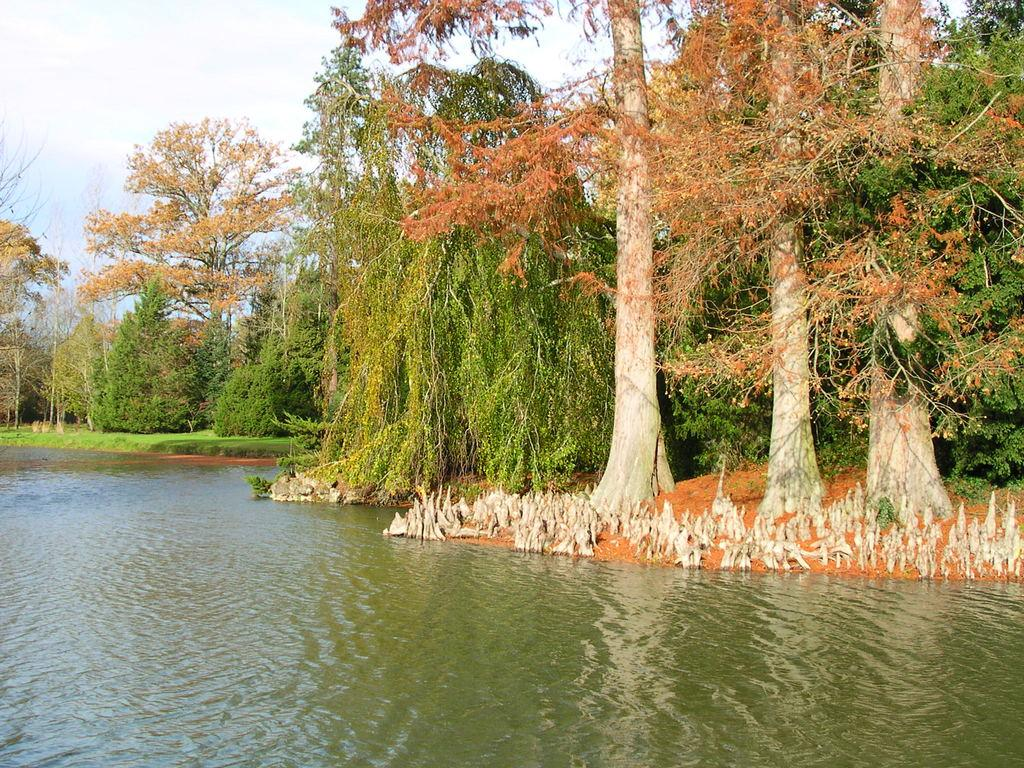What is in the front of the image? There is water in the front of the image. What can be seen in the background of the image? There are trees and grass in the background of the image. What else is visible in the background of the image? The sky is visible in the background of the image. What type of basket is hanging from the tree in the image? There is no basket present in the image; it only features water, trees, grass, and the sky. What belief system is depicted in the image? There is no specific belief system depicted in the image; it is a natural scene with water, trees, grass, and the sky. 